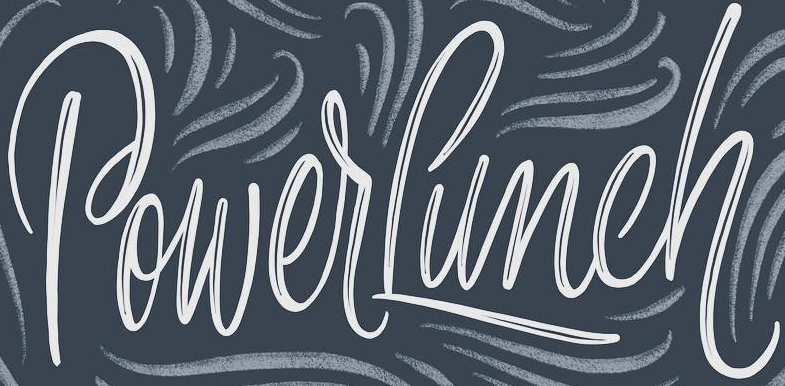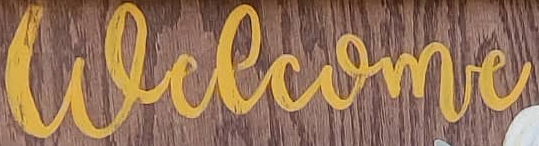What words are shown in these images in order, separated by a semicolon? PowerLunch; welcome 